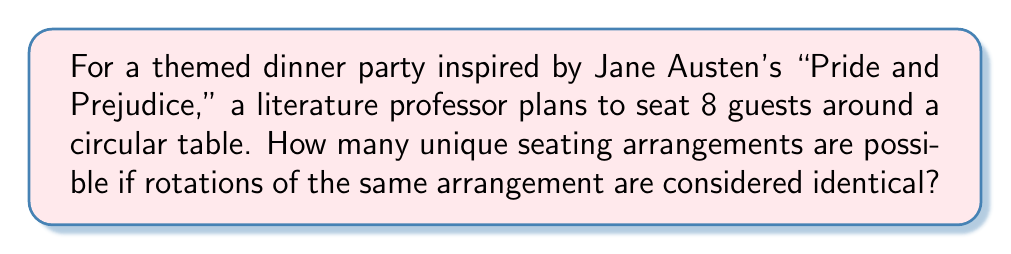Provide a solution to this math problem. Let's approach this step-by-step:

1) First, we need to recognize that this is a circular permutation problem. In a circular arrangement, rotations are considered the same, so we need to use the formula for circular permutations.

2) The formula for circular permutations of $n$ distinct objects is:

   $$(n-1)!$$

3) In this case, we have 8 guests, so $n = 8$.

4) Applying the formula:

   $$(8-1)! = 7!$$

5) Let's calculate 7!:

   $$7! = 7 \times 6 \times 5 \times 4 \times 3 \times 2 \times 1 = 5040$$

Therefore, there are 5040 unique seating arrangements for the 8 guests at the themed dinner party.
Answer: 5040 